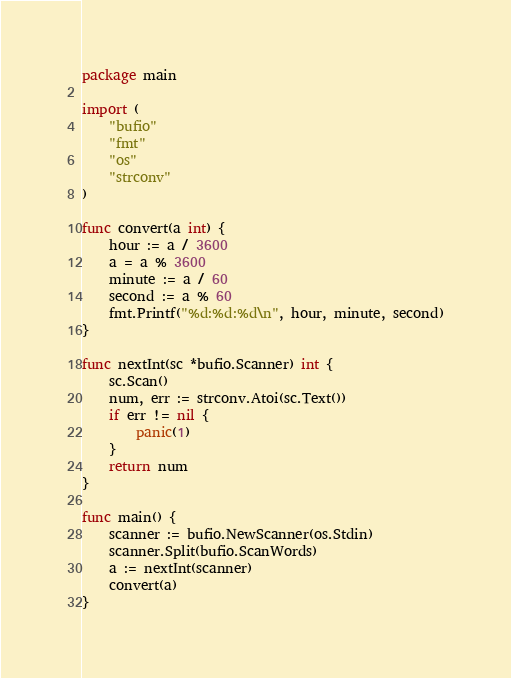<code> <loc_0><loc_0><loc_500><loc_500><_Go_>package main

import (
	"bufio"
	"fmt"
	"os"
	"strconv"
)

func convert(a int) {
	hour := a / 3600
	a = a % 3600
	minute := a / 60
	second := a % 60
	fmt.Printf("%d:%d:%d\n", hour, minute, second)
}

func nextInt(sc *bufio.Scanner) int {
	sc.Scan()
	num, err := strconv.Atoi(sc.Text())
	if err != nil {
		panic(1)
	}
	return num
}

func main() {
	scanner := bufio.NewScanner(os.Stdin)
	scanner.Split(bufio.ScanWords)
	a := nextInt(scanner)
	convert(a)
}

</code> 